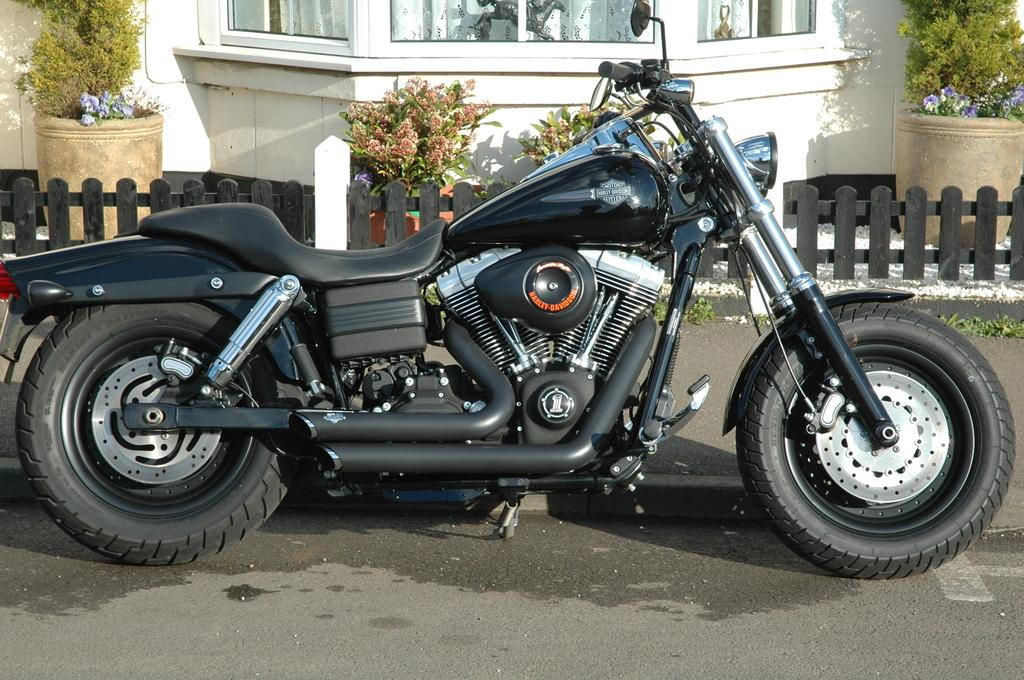What type of vehicle is on the road in the image? There is a motorbike on the road in the image. What can be seen in the background of the image? There is a building, plants, flowers, pots, and a wooden fence in the background of the image. Can you describe the plants in the background? The plants in the background include flowers and are contained in pots. What type of barrier is visible in the background of the image? A wooden fence is observable in the background of the image. How many cows are grazing in the background of the image? There are no cows present in the image; the background features a building, plants, flowers, pots, and a wooden fence. 